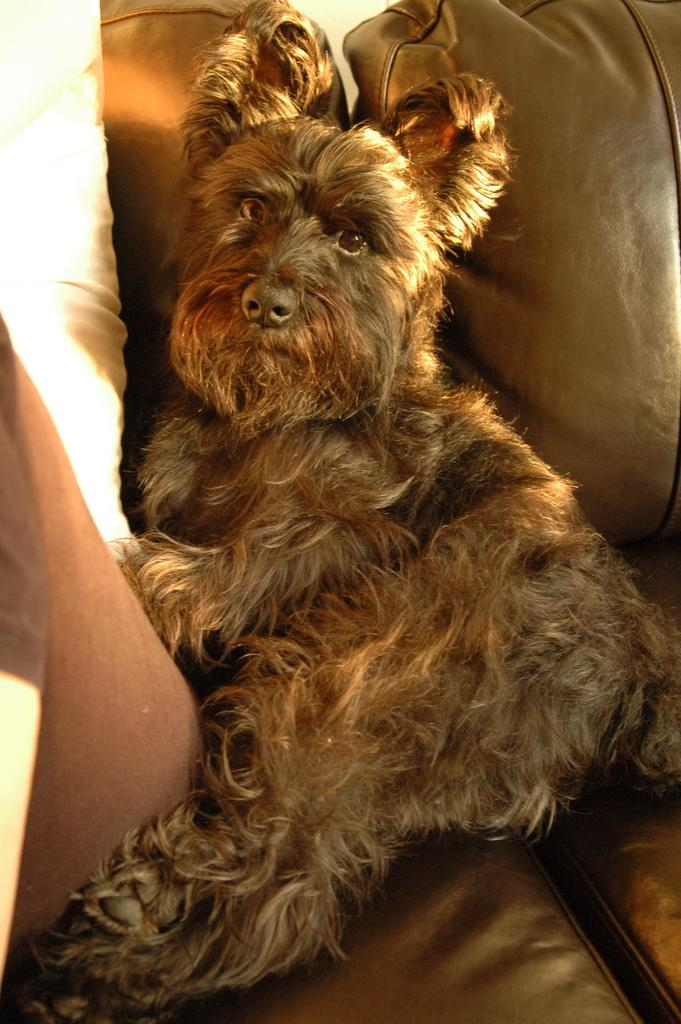What type of animal is present in the image? There is a dog in the image. What objects are also visible in the image? There are pillows in the image. How many dinosaurs can be seen interacting with the dog in the image? There are no dinosaurs present in the image; it features a dog and pillows. What type of flower is growing on the mountain in the image? There is no mountain or flower present in the image. 